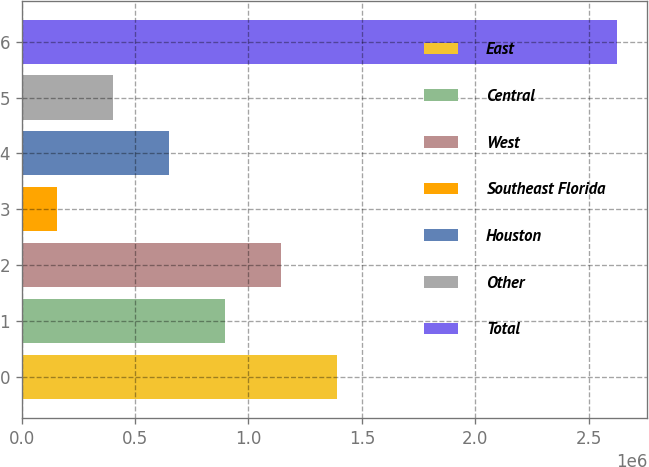<chart> <loc_0><loc_0><loc_500><loc_500><bar_chart><fcel>East<fcel>Central<fcel>West<fcel>Southeast Florida<fcel>Houston<fcel>Other<fcel>Total<nl><fcel>1.39152e+06<fcel>897480<fcel>1.1445e+06<fcel>156424<fcel>650461<fcel>403443<fcel>2.62661e+06<nl></chart> 